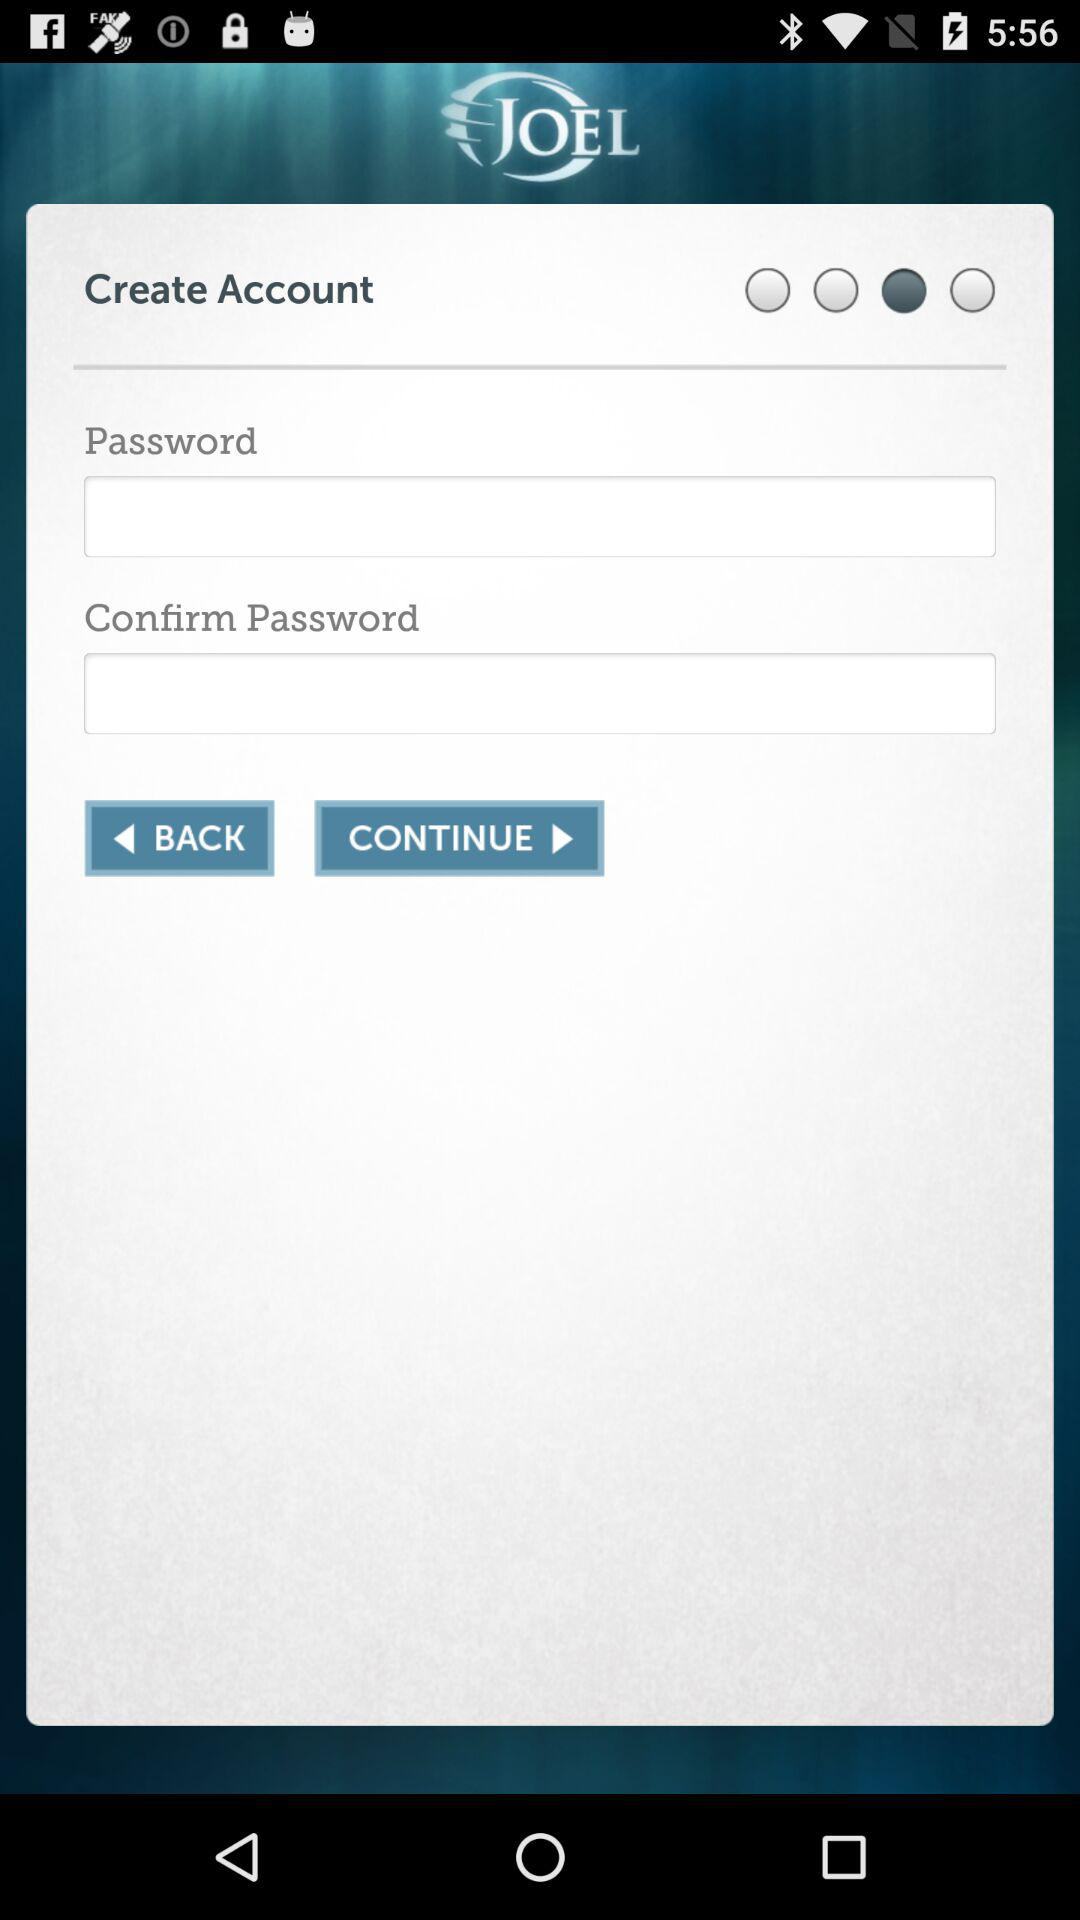What is the name of the application? The name of the application is "JOEL". 